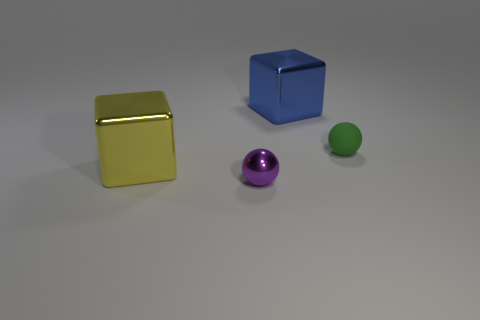Add 1 large blue blocks. How many objects exist? 5 Subtract all purple spheres. How many spheres are left? 1 Subtract 0 red cubes. How many objects are left? 4 Subtract 1 balls. How many balls are left? 1 Subtract all green balls. Subtract all blue cubes. How many balls are left? 1 Subtract all cyan balls. How many blue blocks are left? 1 Subtract all green rubber things. Subtract all tiny purple metal things. How many objects are left? 2 Add 3 yellow blocks. How many yellow blocks are left? 4 Add 4 large yellow objects. How many large yellow objects exist? 5 